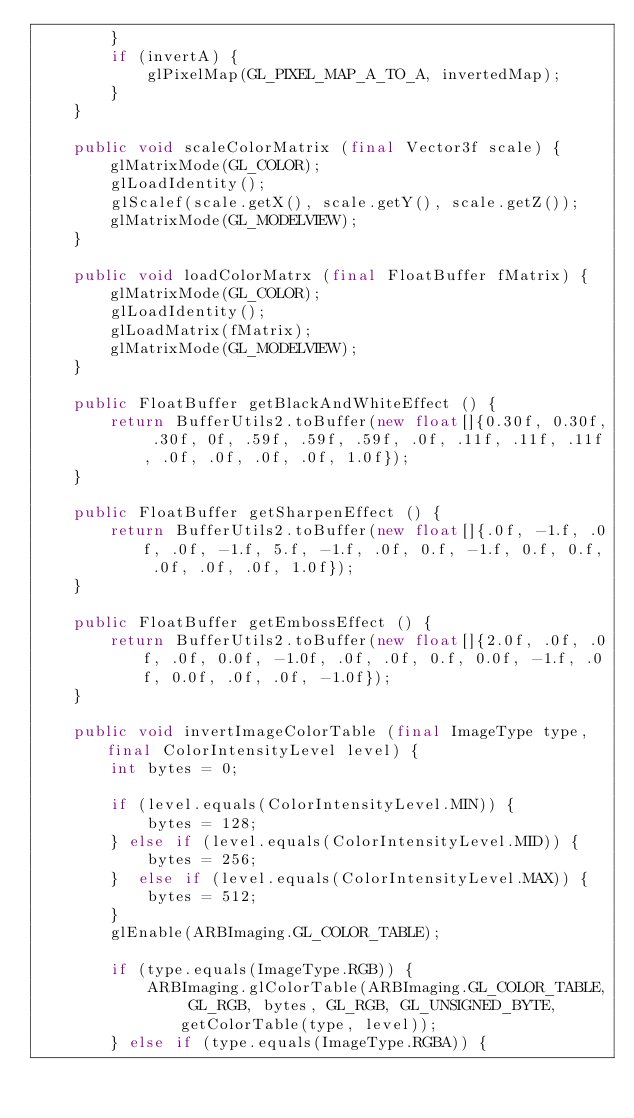Convert code to text. <code><loc_0><loc_0><loc_500><loc_500><_Java_>        }
        if (invertA) {
            glPixelMap(GL_PIXEL_MAP_A_TO_A, invertedMap);
        }
    }

    public void scaleColorMatrix (final Vector3f scale) {
        glMatrixMode(GL_COLOR);
        glLoadIdentity();
        glScalef(scale.getX(), scale.getY(), scale.getZ());
        glMatrixMode(GL_MODELVIEW);
    }

    public void loadColorMatrx (final FloatBuffer fMatrix) {
        glMatrixMode(GL_COLOR);
        glLoadIdentity();
        glLoadMatrix(fMatrix);
        glMatrixMode(GL_MODELVIEW);
    }

    public FloatBuffer getBlackAndWhiteEffect () {
        return BufferUtils2.toBuffer(new float[]{0.30f, 0.30f, .30f, 0f, .59f, .59f, .59f, .0f, .11f, .11f, .11f, .0f, .0f, .0f, .0f, 1.0f});
    }

    public FloatBuffer getSharpenEffect () {
        return BufferUtils2.toBuffer(new float[]{.0f, -1.f, .0f, .0f, -1.f, 5.f, -1.f, .0f, 0.f, -1.f, 0.f, 0.f, .0f, .0f, .0f, 1.0f});
    }

    public FloatBuffer getEmbossEffect () {
        return BufferUtils2.toBuffer(new float[]{2.0f, .0f, .0f, .0f, 0.0f, -1.0f, .0f, .0f, 0.f, 0.0f, -1.f, .0f, 0.0f, .0f, .0f, -1.0f});
    }

    public void invertImageColorTable (final ImageType type, final ColorIntensityLevel level) {
        int bytes = 0;

        if (level.equals(ColorIntensityLevel.MIN)) {
            bytes = 128;
        } else if (level.equals(ColorIntensityLevel.MID)) {
            bytes = 256;
        }  else if (level.equals(ColorIntensityLevel.MAX)) {
            bytes = 512;
        }
        glEnable(ARBImaging.GL_COLOR_TABLE);

        if (type.equals(ImageType.RGB)) {
            ARBImaging.glColorTable(ARBImaging.GL_COLOR_TABLE, GL_RGB, bytes, GL_RGB, GL_UNSIGNED_BYTE, getColorTable(type, level));
        } else if (type.equals(ImageType.RGBA)) {</code> 